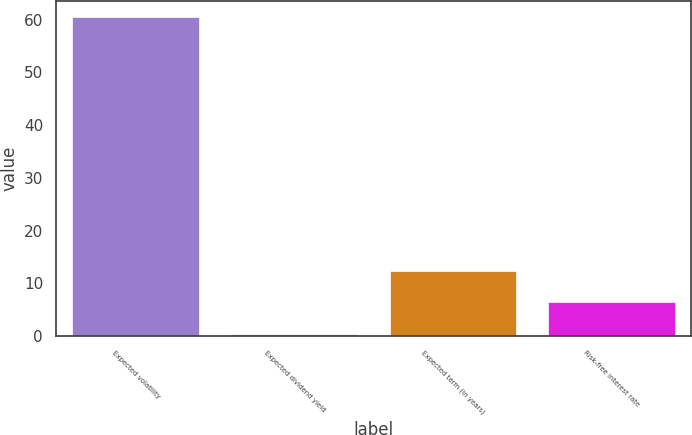Convert chart to OTSL. <chart><loc_0><loc_0><loc_500><loc_500><bar_chart><fcel>Expected volatility<fcel>Expected dividend yield<fcel>Expected term (in years)<fcel>Risk-free interest rate<nl><fcel>60.46<fcel>0.44<fcel>12.44<fcel>6.44<nl></chart> 